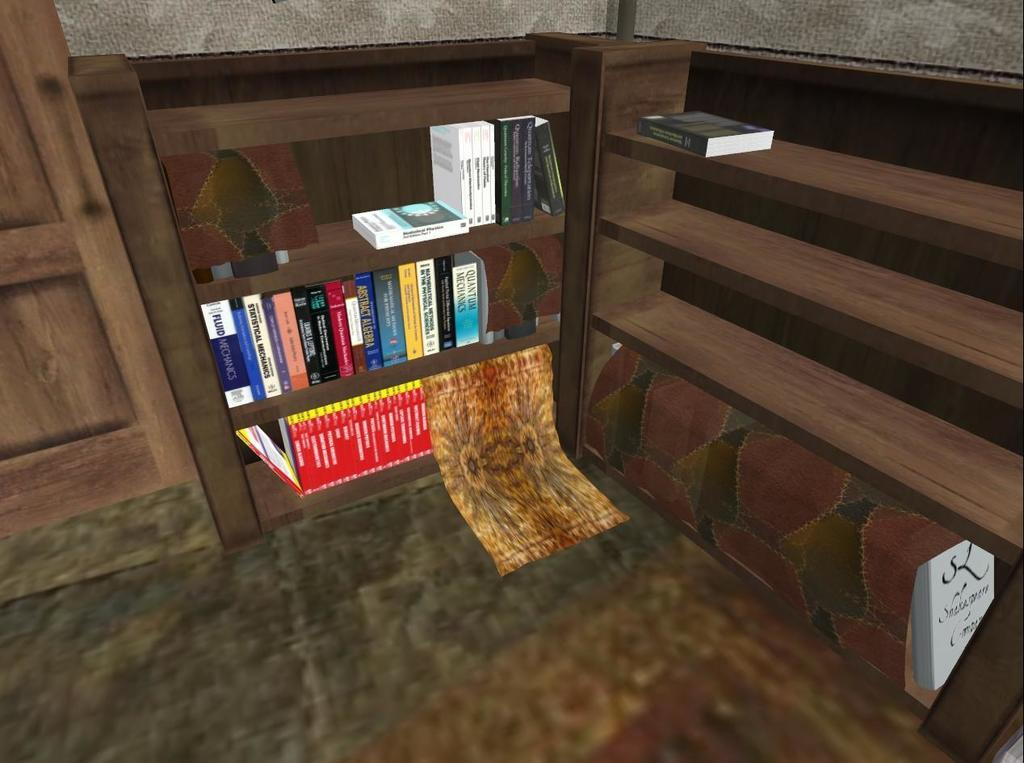What type of image is this? The image is an anime depiction of a room. What can be seen in the room? There are books in a wooden rack in the room. Where is the door located in the room? There is a door on the left side of the room. What type of hospital equipment can be seen in the image? There is no hospital equipment present in the image, as it is a depiction of a room in an anime style. How does the pollution affect the room in the image? There is no mention of pollution in the image, as it is a depiction of a room in an anime style. 